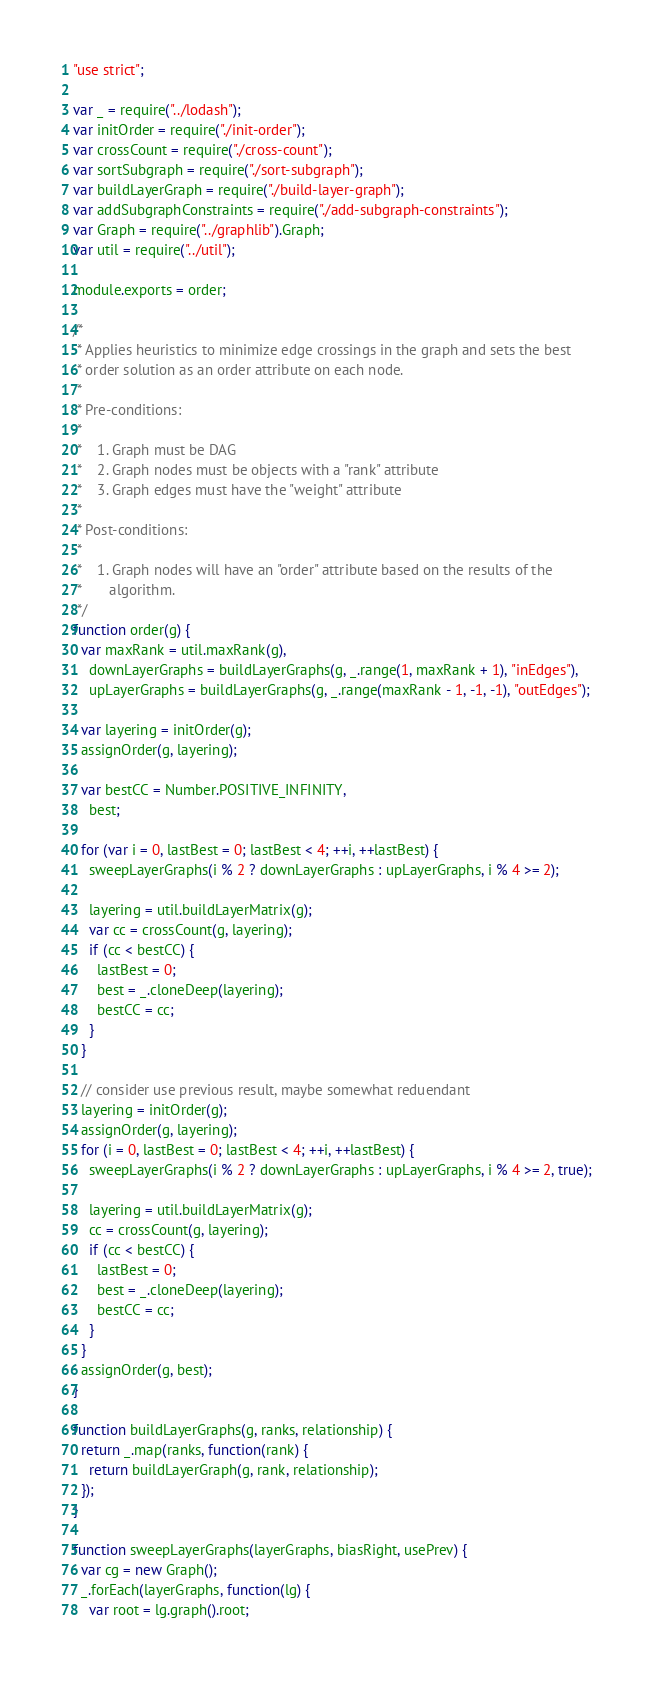Convert code to text. <code><loc_0><loc_0><loc_500><loc_500><_JavaScript_>"use strict";

var _ = require("../lodash");
var initOrder = require("./init-order");
var crossCount = require("./cross-count");
var sortSubgraph = require("./sort-subgraph");
var buildLayerGraph = require("./build-layer-graph");
var addSubgraphConstraints = require("./add-subgraph-constraints");
var Graph = require("../graphlib").Graph;
var util = require("../util");

module.exports = order;

/*
 * Applies heuristics to minimize edge crossings in the graph and sets the best
 * order solution as an order attribute on each node.
 *
 * Pre-conditions:
 *
 *    1. Graph must be DAG
 *    2. Graph nodes must be objects with a "rank" attribute
 *    3. Graph edges must have the "weight" attribute
 *
 * Post-conditions:
 *
 *    1. Graph nodes will have an "order" attribute based on the results of the
 *       algorithm.
 */
function order(g) {
  var maxRank = util.maxRank(g),
    downLayerGraphs = buildLayerGraphs(g, _.range(1, maxRank + 1), "inEdges"),
    upLayerGraphs = buildLayerGraphs(g, _.range(maxRank - 1, -1, -1), "outEdges");

  var layering = initOrder(g);
  assignOrder(g, layering);

  var bestCC = Number.POSITIVE_INFINITY,
    best;

  for (var i = 0, lastBest = 0; lastBest < 4; ++i, ++lastBest) {
    sweepLayerGraphs(i % 2 ? downLayerGraphs : upLayerGraphs, i % 4 >= 2);

    layering = util.buildLayerMatrix(g);
    var cc = crossCount(g, layering);
    if (cc < bestCC) {
      lastBest = 0;
      best = _.cloneDeep(layering);
      bestCC = cc;
    }
  }

  // consider use previous result, maybe somewhat reduendant
  layering = initOrder(g);
  assignOrder(g, layering);
  for (i = 0, lastBest = 0; lastBest < 4; ++i, ++lastBest) {
    sweepLayerGraphs(i % 2 ? downLayerGraphs : upLayerGraphs, i % 4 >= 2, true);

    layering = util.buildLayerMatrix(g);
    cc = crossCount(g, layering);
    if (cc < bestCC) {
      lastBest = 0;
      best = _.cloneDeep(layering);
      bestCC = cc;
    }
  }
  assignOrder(g, best);
}

function buildLayerGraphs(g, ranks, relationship) {
  return _.map(ranks, function(rank) {
    return buildLayerGraph(g, rank, relationship);
  });
}

function sweepLayerGraphs(layerGraphs, biasRight, usePrev) {
  var cg = new Graph();
  _.forEach(layerGraphs, function(lg) {
    var root = lg.graph().root;</code> 